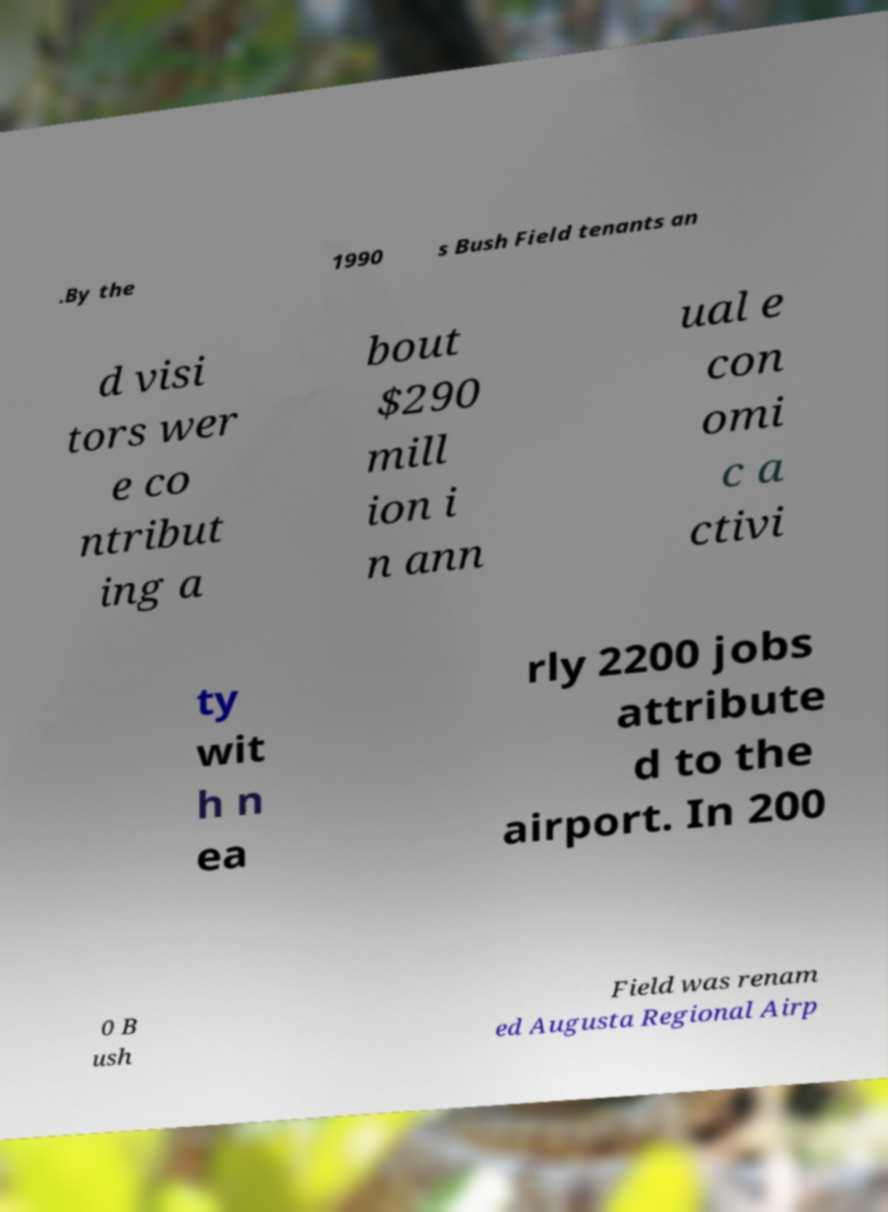Can you read and provide the text displayed in the image?This photo seems to have some interesting text. Can you extract and type it out for me? .By the 1990 s Bush Field tenants an d visi tors wer e co ntribut ing a bout $290 mill ion i n ann ual e con omi c a ctivi ty wit h n ea rly 2200 jobs attribute d to the airport. In 200 0 B ush Field was renam ed Augusta Regional Airp 